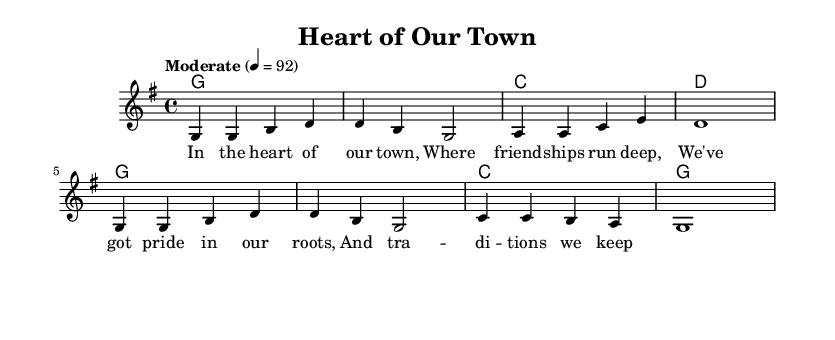What is the key signature of this music? The key signature is G major, which has one sharp (F#) indicated at the beginning of the staff.
Answer: G major What is the time signature of this piece? The time signature is indicated by the numbers at the beginning of the staff and shows that there are four beats in each measure.
Answer: 4/4 What is the tempo marking of this piece? The tempo marking indicates the pace of the music and is shown at the beginning; it indicates a moderate speed of 92 beats per minute.
Answer: Moderate 4 = 92 How many measures are in the melody? Counting the distinct groupings of notes separated by bars, there are a total of eight measures in the melody.
Answer: 8 What is the first chord in the harmonies? The first chord is the beginning of the chord progression, which is indicated in the harmonies section, showing it starts with a G chord.
Answer: G What is the lyrical theme of the song? The lyrics express local pride and community spirit through the imagery of friendship and traditions in a small town, evident in the words depicted in the lyrics.
Answer: Pride in our roots Which voice is used for the melody? The voice labeled "main" is the one that is used for the melody, as indicated at the beginning of the staff where the melody is placed.
Answer: main 